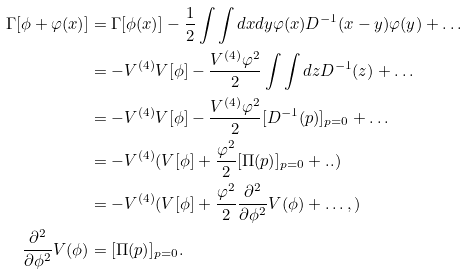Convert formula to latex. <formula><loc_0><loc_0><loc_500><loc_500>\Gamma [ \phi + \varphi ( x ) ] & = \Gamma [ \phi ( x ) ] - \frac { 1 } { 2 } \int \int d x d y \varphi ( x ) D ^ { - 1 } ( x - y ) \varphi ( y ) + \dots \\ & = - V ^ { ( 4 ) } V [ \phi ] - \frac { V ^ { ( 4 ) } \varphi ^ { 2 } } { 2 } \int \int d z D ^ { - 1 } ( z ) + \dots \\ & = - V ^ { ( 4 ) } V [ \phi ] - \frac { V ^ { ( 4 ) } \varphi ^ { 2 } } { 2 } [ D ^ { - 1 } ( p ) ] _ { p = 0 } + \dots \\ & = - V ^ { ( 4 ) } ( V [ \phi ] + \frac { \varphi ^ { 2 } } { 2 } [ \Pi ( p ) ] _ { p = 0 } + . . ) \\ & = - V ^ { ( 4 ) } ( V [ \phi ] + \frac { \varphi ^ { 2 } } { 2 } \frac { \partial ^ { 2 } } { \partial \phi ^ { 2 } } V ( \phi ) + \dots , ) \\ \frac { \partial ^ { 2 } } { \partial \phi ^ { 2 } } V ( \phi ) & = [ \Pi ( p ) ] _ { p = 0 } .</formula> 